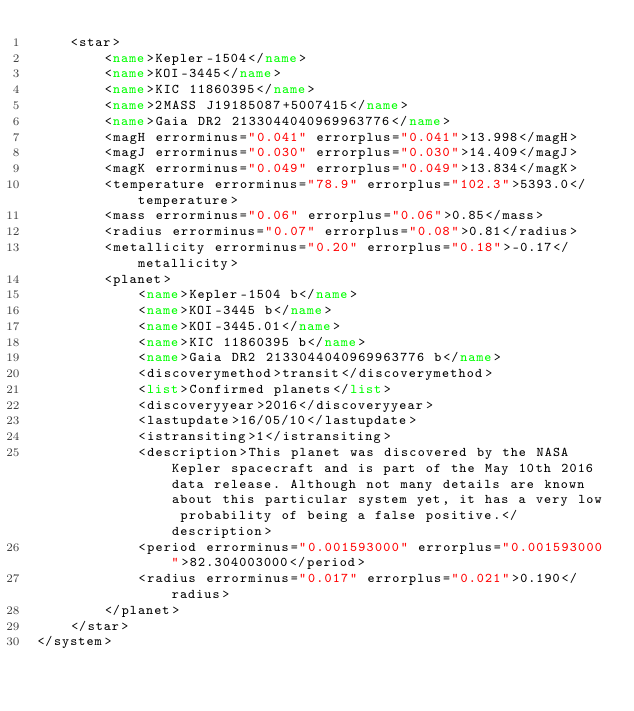<code> <loc_0><loc_0><loc_500><loc_500><_XML_>	<star>
		<name>Kepler-1504</name>
		<name>KOI-3445</name>
		<name>KIC 11860395</name>
		<name>2MASS J19185087+5007415</name>
		<name>Gaia DR2 2133044040969963776</name>
		<magH errorminus="0.041" errorplus="0.041">13.998</magH>
		<magJ errorminus="0.030" errorplus="0.030">14.409</magJ>
		<magK errorminus="0.049" errorplus="0.049">13.834</magK>
		<temperature errorminus="78.9" errorplus="102.3">5393.0</temperature>
		<mass errorminus="0.06" errorplus="0.06">0.85</mass>
		<radius errorminus="0.07" errorplus="0.08">0.81</radius>
		<metallicity errorminus="0.20" errorplus="0.18">-0.17</metallicity>
		<planet>
			<name>Kepler-1504 b</name>
			<name>KOI-3445 b</name>
			<name>KOI-3445.01</name>
			<name>KIC 11860395 b</name>
			<name>Gaia DR2 2133044040969963776 b</name>
			<discoverymethod>transit</discoverymethod>
			<list>Confirmed planets</list>
			<discoveryyear>2016</discoveryyear>
			<lastupdate>16/05/10</lastupdate>
			<istransiting>1</istransiting>
			<description>This planet was discovered by the NASA Kepler spacecraft and is part of the May 10th 2016 data release. Although not many details are known about this particular system yet, it has a very low probability of being a false positive.</description>
			<period errorminus="0.001593000" errorplus="0.001593000">82.304003000</period>
			<radius errorminus="0.017" errorplus="0.021">0.190</radius>
		</planet>
	</star>
</system>
</code> 